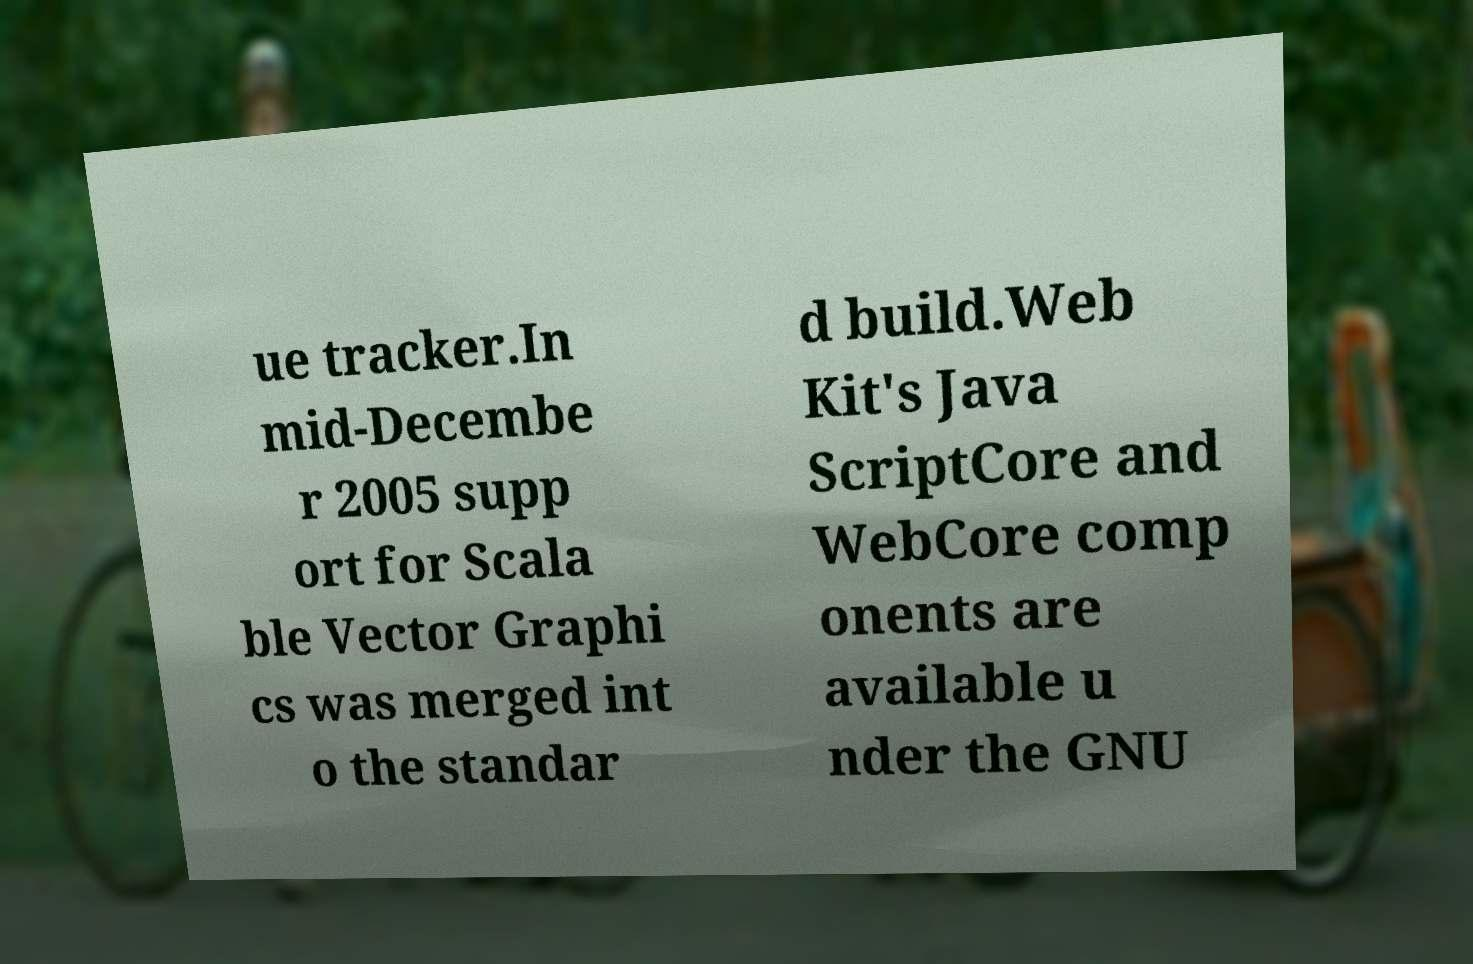I need the written content from this picture converted into text. Can you do that? ue tracker.In mid-Decembe r 2005 supp ort for Scala ble Vector Graphi cs was merged int o the standar d build.Web Kit's Java ScriptCore and WebCore comp onents are available u nder the GNU 